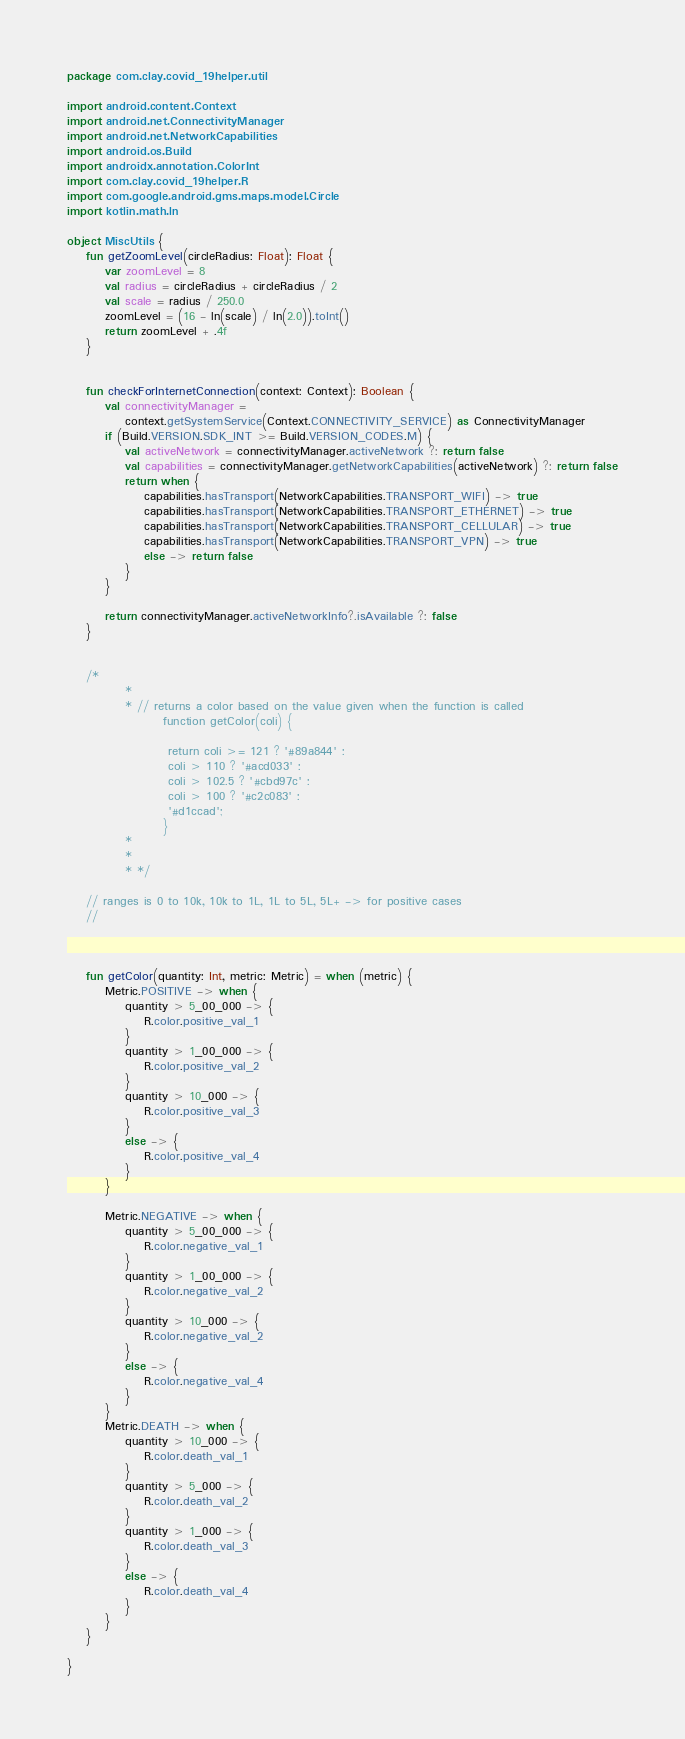Convert code to text. <code><loc_0><loc_0><loc_500><loc_500><_Kotlin_>package com.clay.covid_19helper.util

import android.content.Context
import android.net.ConnectivityManager
import android.net.NetworkCapabilities
import android.os.Build
import androidx.annotation.ColorInt
import com.clay.covid_19helper.R
import com.google.android.gms.maps.model.Circle
import kotlin.math.ln

object MiscUtils {
    fun getZoomLevel(circleRadius: Float): Float {
        var zoomLevel = 8
        val radius = circleRadius + circleRadius / 2
        val scale = radius / 250.0
        zoomLevel = (16 - ln(scale) / ln(2.0)).toInt()
        return zoomLevel + .4f
    }


    fun checkForInternetConnection(context: Context): Boolean {
        val connectivityManager =
            context.getSystemService(Context.CONNECTIVITY_SERVICE) as ConnectivityManager
        if (Build.VERSION.SDK_INT >= Build.VERSION_CODES.M) {
            val activeNetwork = connectivityManager.activeNetwork ?: return false
            val capabilities = connectivityManager.getNetworkCapabilities(activeNetwork) ?: return false
            return when {
                capabilities.hasTransport(NetworkCapabilities.TRANSPORT_WIFI) -> true
                capabilities.hasTransport(NetworkCapabilities.TRANSPORT_ETHERNET) -> true
                capabilities.hasTransport(NetworkCapabilities.TRANSPORT_CELLULAR) -> true
                capabilities.hasTransport(NetworkCapabilities.TRANSPORT_VPN) -> true
                else -> return false
            }
        }

        return connectivityManager.activeNetworkInfo?.isAvailable ?: false
    }


    /*
            *
            * // returns a color based on the value given when the function is called
                    function getColor(coli) {

                     return coli >= 121 ? '#89a844' :
                     coli > 110 ? '#acd033' :
                     coli > 102.5 ? '#cbd97c' :
                     coli > 100 ? '#c2c083' :
                     '#d1ccad';
                    }
            *
            *
            * */

    // ranges is 0 to 10k, 10k to 1L, 1L to 5L, 5L+ -> for positive cases
    //



    fun getColor(quantity: Int, metric: Metric) = when (metric) {
        Metric.POSITIVE -> when {
            quantity > 5_00_000 -> {
                R.color.positive_val_1
            }
            quantity > 1_00_000 -> {
                R.color.positive_val_2
            }
            quantity > 10_000 -> {
                R.color.positive_val_3
            }
            else -> {
                R.color.positive_val_4
            }
        }

        Metric.NEGATIVE -> when {
            quantity > 5_00_000 -> {
                R.color.negative_val_1
            }
            quantity > 1_00_000 -> {
                R.color.negative_val_2
            }
            quantity > 10_000 -> {
                R.color.negative_val_2
            }
            else -> {
                R.color.negative_val_4
            }
        }
        Metric.DEATH -> when {
            quantity > 10_000 -> {
                R.color.death_val_1
            }
            quantity > 5_000 -> {
                R.color.death_val_2
            }
            quantity > 1_000 -> {
                R.color.death_val_3
            }
            else -> {
                R.color.death_val_4
            }
        }
    }

}</code> 